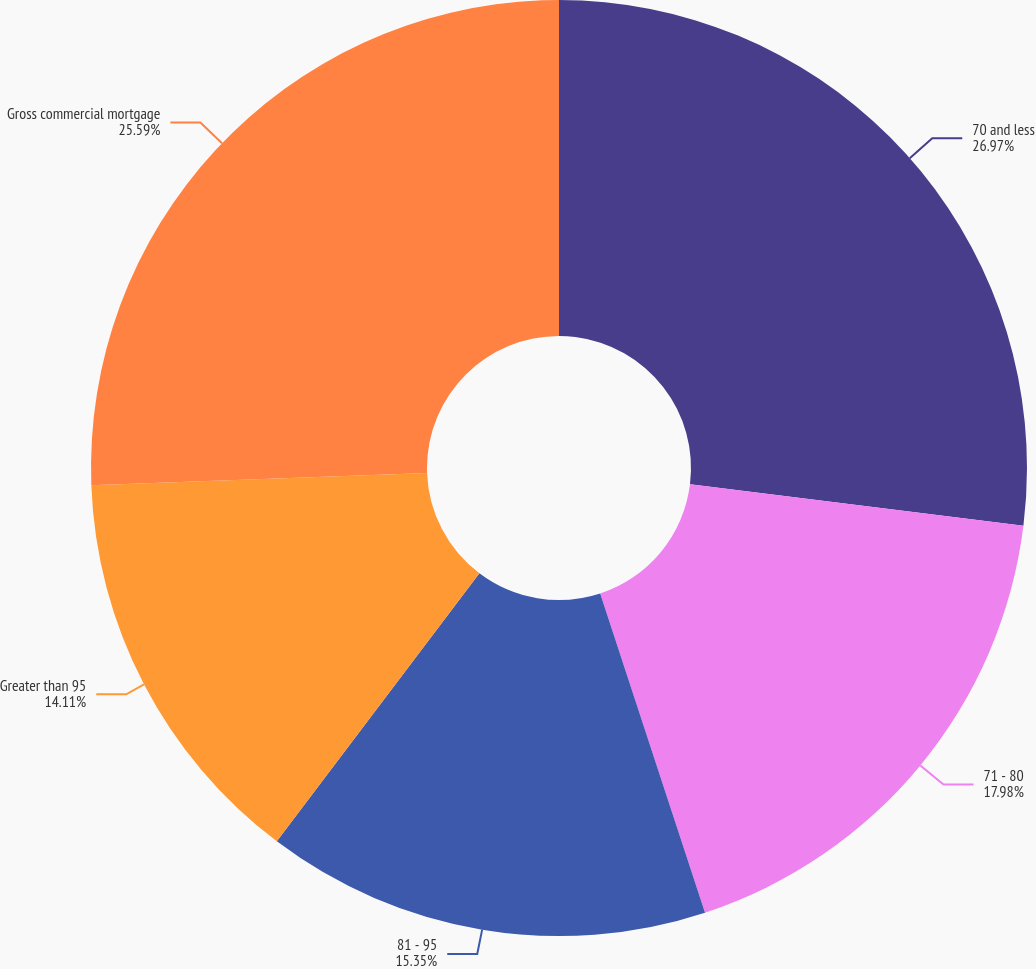Convert chart. <chart><loc_0><loc_0><loc_500><loc_500><pie_chart><fcel>70 and less<fcel>71 - 80<fcel>81 - 95<fcel>Greater than 95<fcel>Gross commercial mortgage<nl><fcel>26.97%<fcel>17.98%<fcel>15.35%<fcel>14.11%<fcel>25.59%<nl></chart> 